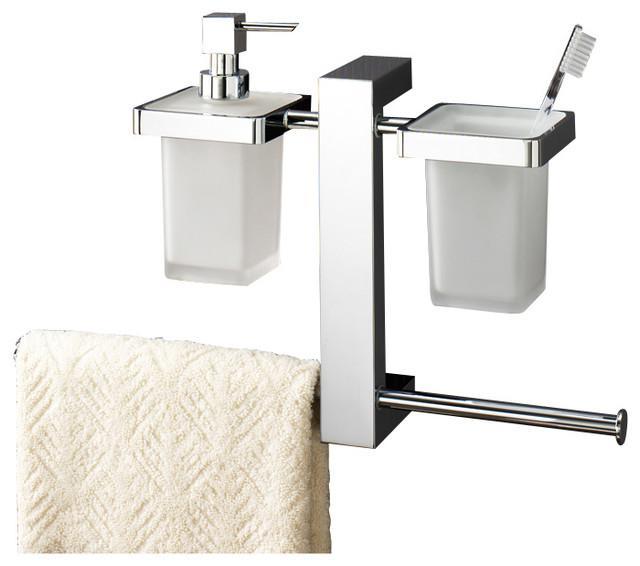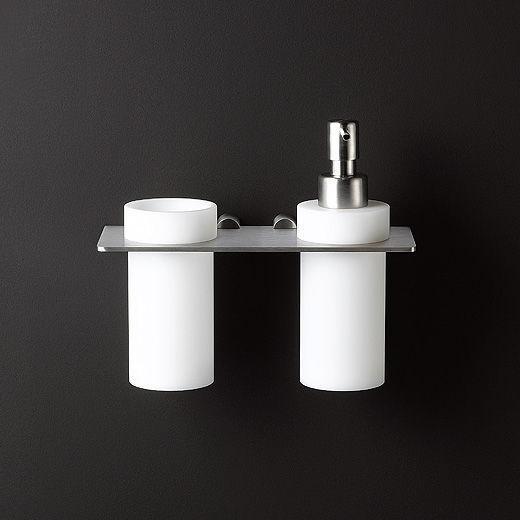The first image is the image on the left, the second image is the image on the right. Assess this claim about the two images: "Each image contains one cylindrical pump-top dispenser that mounts alone on a wall and has a chrome top and narrow band around it.". Correct or not? Answer yes or no. No. 